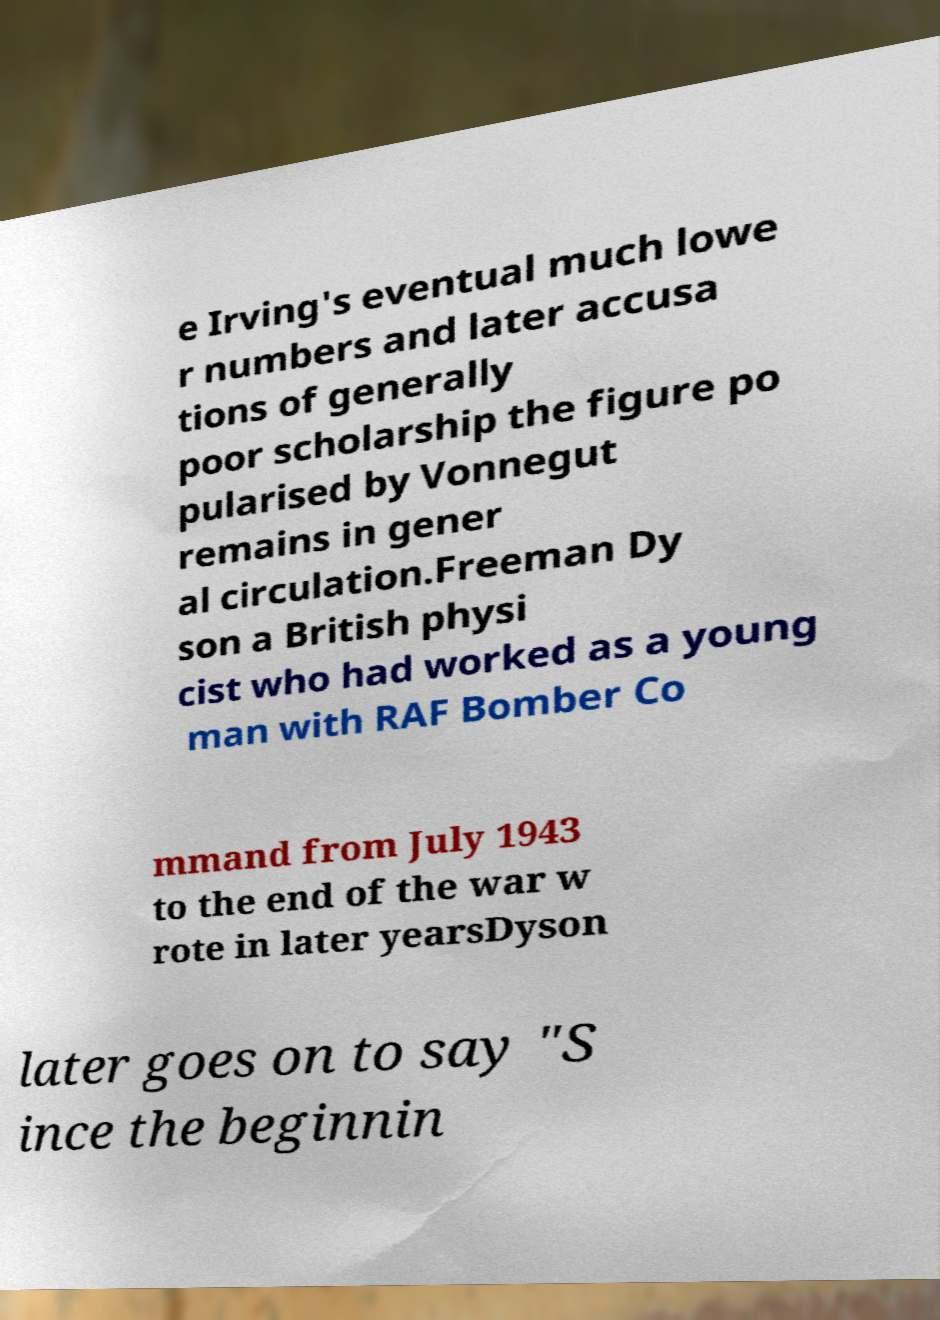Could you assist in decoding the text presented in this image and type it out clearly? e Irving's eventual much lowe r numbers and later accusa tions of generally poor scholarship the figure po pularised by Vonnegut remains in gener al circulation.Freeman Dy son a British physi cist who had worked as a young man with RAF Bomber Co mmand from July 1943 to the end of the war w rote in later yearsDyson later goes on to say "S ince the beginnin 